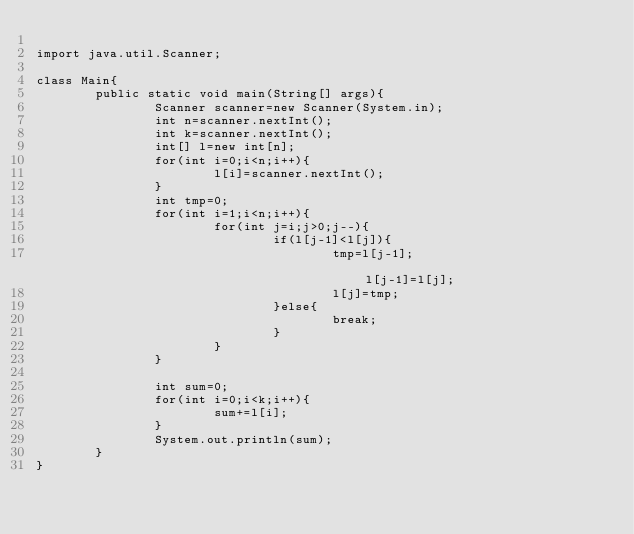<code> <loc_0><loc_0><loc_500><loc_500><_Java_>
import java.util.Scanner;

class Main{
        public static void main(String[] args){
                Scanner scanner=new Scanner(System.in);
                int n=scanner.nextInt();
                int k=scanner.nextInt();
                int[] l=new int[n];
                for(int i=0;i<n;i++){
                        l[i]=scanner.nextInt();
                }
                int tmp=0;
                for(int i=1;i<n;i++){
                        for(int j=i;j>0;j--){
                                if(l[j-1]<l[j]){
                                        tmp=l[j-1];                                        l[j-1]=l[j];
                                        l[j]=tmp;
                                }else{
                                        break;
                                }
                        }
                }

                int sum=0;
                for(int i=0;i<k;i++){
                        sum+=l[i];
                }
                System.out.println(sum);
        }
}</code> 